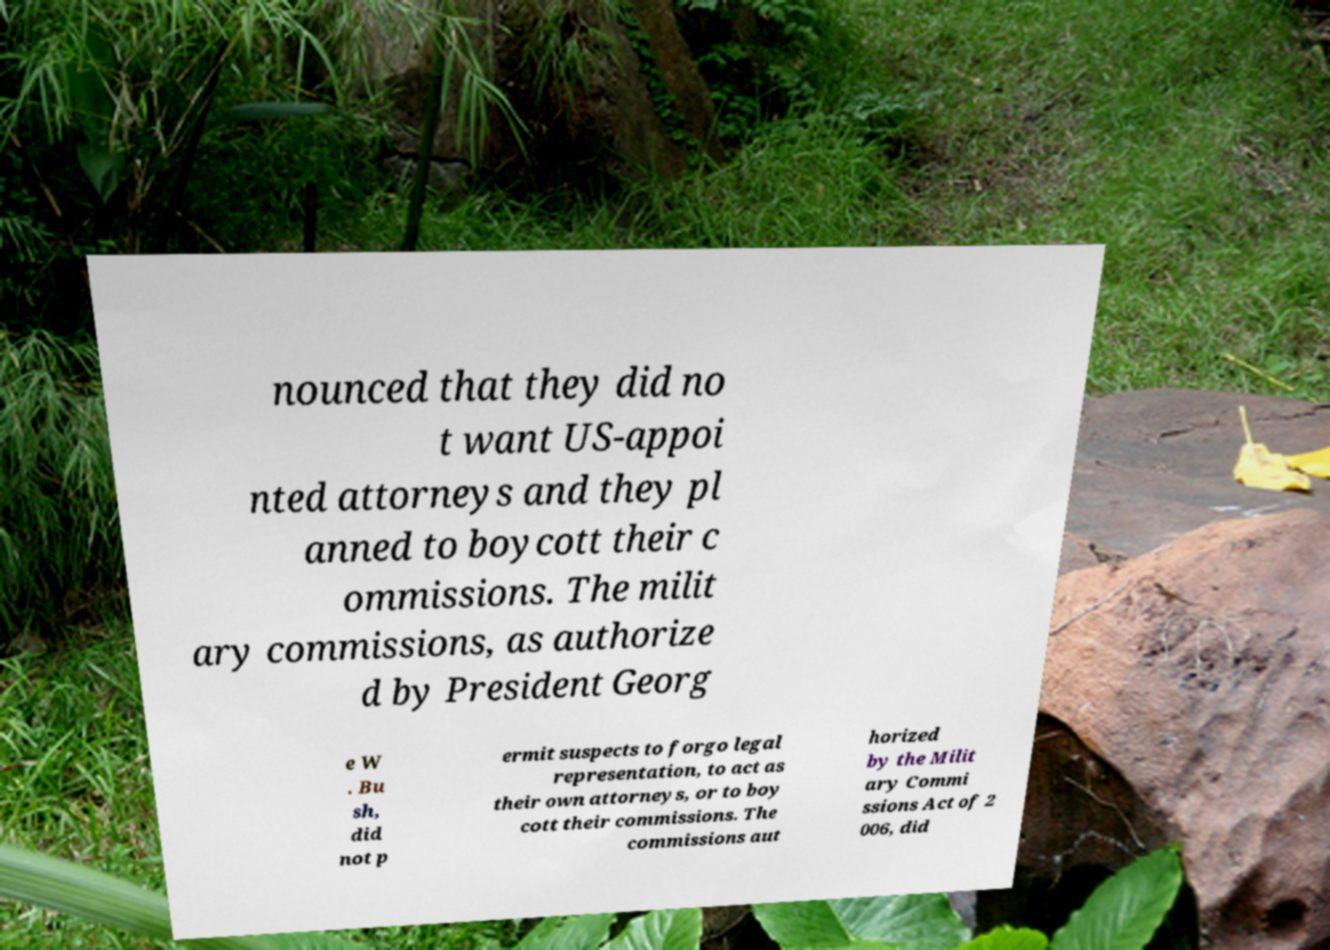I need the written content from this picture converted into text. Can you do that? nounced that they did no t want US-appoi nted attorneys and they pl anned to boycott their c ommissions. The milit ary commissions, as authorize d by President Georg e W . Bu sh, did not p ermit suspects to forgo legal representation, to act as their own attorneys, or to boy cott their commissions. The commissions aut horized by the Milit ary Commi ssions Act of 2 006, did 